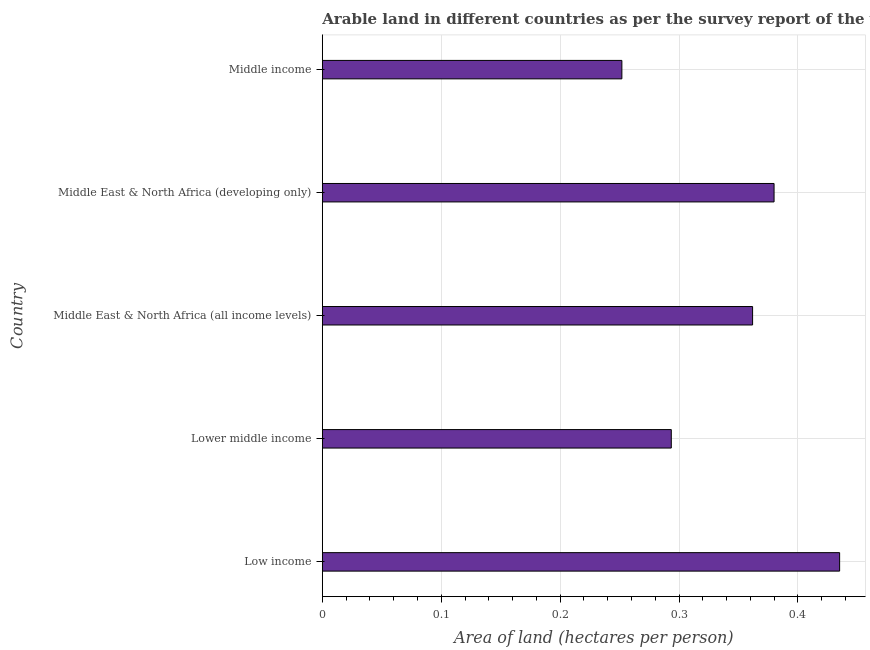What is the title of the graph?
Make the answer very short. Arable land in different countries as per the survey report of the year 1970. What is the label or title of the X-axis?
Give a very brief answer. Area of land (hectares per person). What is the label or title of the Y-axis?
Offer a very short reply. Country. What is the area of arable land in Middle East & North Africa (all income levels)?
Provide a short and direct response. 0.36. Across all countries, what is the maximum area of arable land?
Offer a very short reply. 0.44. Across all countries, what is the minimum area of arable land?
Your answer should be compact. 0.25. In which country was the area of arable land minimum?
Your answer should be compact. Middle income. What is the sum of the area of arable land?
Offer a very short reply. 1.72. What is the difference between the area of arable land in Low income and Lower middle income?
Ensure brevity in your answer.  0.14. What is the average area of arable land per country?
Give a very brief answer. 0.34. What is the median area of arable land?
Ensure brevity in your answer.  0.36. What is the ratio of the area of arable land in Middle East & North Africa (all income levels) to that in Middle income?
Your response must be concise. 1.44. Is the difference between the area of arable land in Low income and Middle East & North Africa (all income levels) greater than the difference between any two countries?
Ensure brevity in your answer.  No. What is the difference between the highest and the second highest area of arable land?
Ensure brevity in your answer.  0.06. What is the difference between the highest and the lowest area of arable land?
Your answer should be compact. 0.18. How many countries are there in the graph?
Provide a succinct answer. 5. Are the values on the major ticks of X-axis written in scientific E-notation?
Offer a very short reply. No. What is the Area of land (hectares per person) of Low income?
Your response must be concise. 0.44. What is the Area of land (hectares per person) in Lower middle income?
Offer a very short reply. 0.29. What is the Area of land (hectares per person) in Middle East & North Africa (all income levels)?
Ensure brevity in your answer.  0.36. What is the Area of land (hectares per person) in Middle East & North Africa (developing only)?
Provide a short and direct response. 0.38. What is the Area of land (hectares per person) of Middle income?
Your response must be concise. 0.25. What is the difference between the Area of land (hectares per person) in Low income and Lower middle income?
Offer a very short reply. 0.14. What is the difference between the Area of land (hectares per person) in Low income and Middle East & North Africa (all income levels)?
Give a very brief answer. 0.07. What is the difference between the Area of land (hectares per person) in Low income and Middle East & North Africa (developing only)?
Offer a terse response. 0.06. What is the difference between the Area of land (hectares per person) in Low income and Middle income?
Offer a very short reply. 0.18. What is the difference between the Area of land (hectares per person) in Lower middle income and Middle East & North Africa (all income levels)?
Offer a very short reply. -0.07. What is the difference between the Area of land (hectares per person) in Lower middle income and Middle East & North Africa (developing only)?
Give a very brief answer. -0.09. What is the difference between the Area of land (hectares per person) in Lower middle income and Middle income?
Offer a terse response. 0.04. What is the difference between the Area of land (hectares per person) in Middle East & North Africa (all income levels) and Middle East & North Africa (developing only)?
Ensure brevity in your answer.  -0.02. What is the difference between the Area of land (hectares per person) in Middle East & North Africa (all income levels) and Middle income?
Your answer should be very brief. 0.11. What is the difference between the Area of land (hectares per person) in Middle East & North Africa (developing only) and Middle income?
Give a very brief answer. 0.13. What is the ratio of the Area of land (hectares per person) in Low income to that in Lower middle income?
Make the answer very short. 1.48. What is the ratio of the Area of land (hectares per person) in Low income to that in Middle East & North Africa (all income levels)?
Give a very brief answer. 1.2. What is the ratio of the Area of land (hectares per person) in Low income to that in Middle East & North Africa (developing only)?
Provide a succinct answer. 1.15. What is the ratio of the Area of land (hectares per person) in Low income to that in Middle income?
Make the answer very short. 1.73. What is the ratio of the Area of land (hectares per person) in Lower middle income to that in Middle East & North Africa (all income levels)?
Your response must be concise. 0.81. What is the ratio of the Area of land (hectares per person) in Lower middle income to that in Middle East & North Africa (developing only)?
Offer a very short reply. 0.77. What is the ratio of the Area of land (hectares per person) in Lower middle income to that in Middle income?
Offer a very short reply. 1.17. What is the ratio of the Area of land (hectares per person) in Middle East & North Africa (all income levels) to that in Middle East & North Africa (developing only)?
Your answer should be compact. 0.95. What is the ratio of the Area of land (hectares per person) in Middle East & North Africa (all income levels) to that in Middle income?
Make the answer very short. 1.44. What is the ratio of the Area of land (hectares per person) in Middle East & North Africa (developing only) to that in Middle income?
Provide a succinct answer. 1.51. 